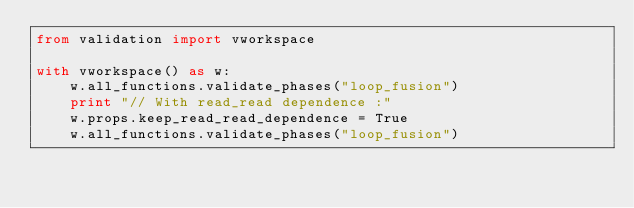<code> <loc_0><loc_0><loc_500><loc_500><_Python_>from validation import vworkspace

with vworkspace() as w:
    w.all_functions.validate_phases("loop_fusion")
    print "// With read_read dependence :"
    w.props.keep_read_read_dependence = True
    w.all_functions.validate_phases("loop_fusion")

</code> 